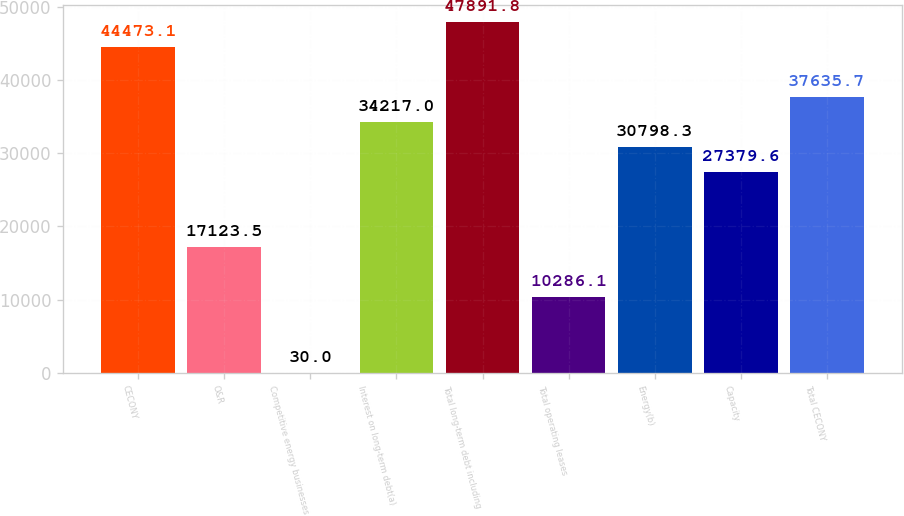Convert chart to OTSL. <chart><loc_0><loc_0><loc_500><loc_500><bar_chart><fcel>CECONY<fcel>O&R<fcel>Competitive energy businesses<fcel>Interest on long-term debt(a)<fcel>Total long-term debt including<fcel>Total operating leases<fcel>Energy(b)<fcel>Capacity<fcel>Total CECONY<nl><fcel>44473.1<fcel>17123.5<fcel>30<fcel>34217<fcel>47891.8<fcel>10286.1<fcel>30798.3<fcel>27379.6<fcel>37635.7<nl></chart> 